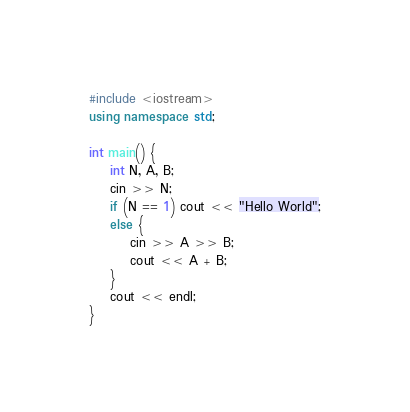Convert code to text. <code><loc_0><loc_0><loc_500><loc_500><_C++_>#include <iostream>
using namespace std;

int main() {
	int N, A, B;
	cin >> N;
	if (N == 1) cout << "Hello World";
	else {
		cin >> A >> B;
		cout << A + B;
	}
	cout << endl;
}</code> 